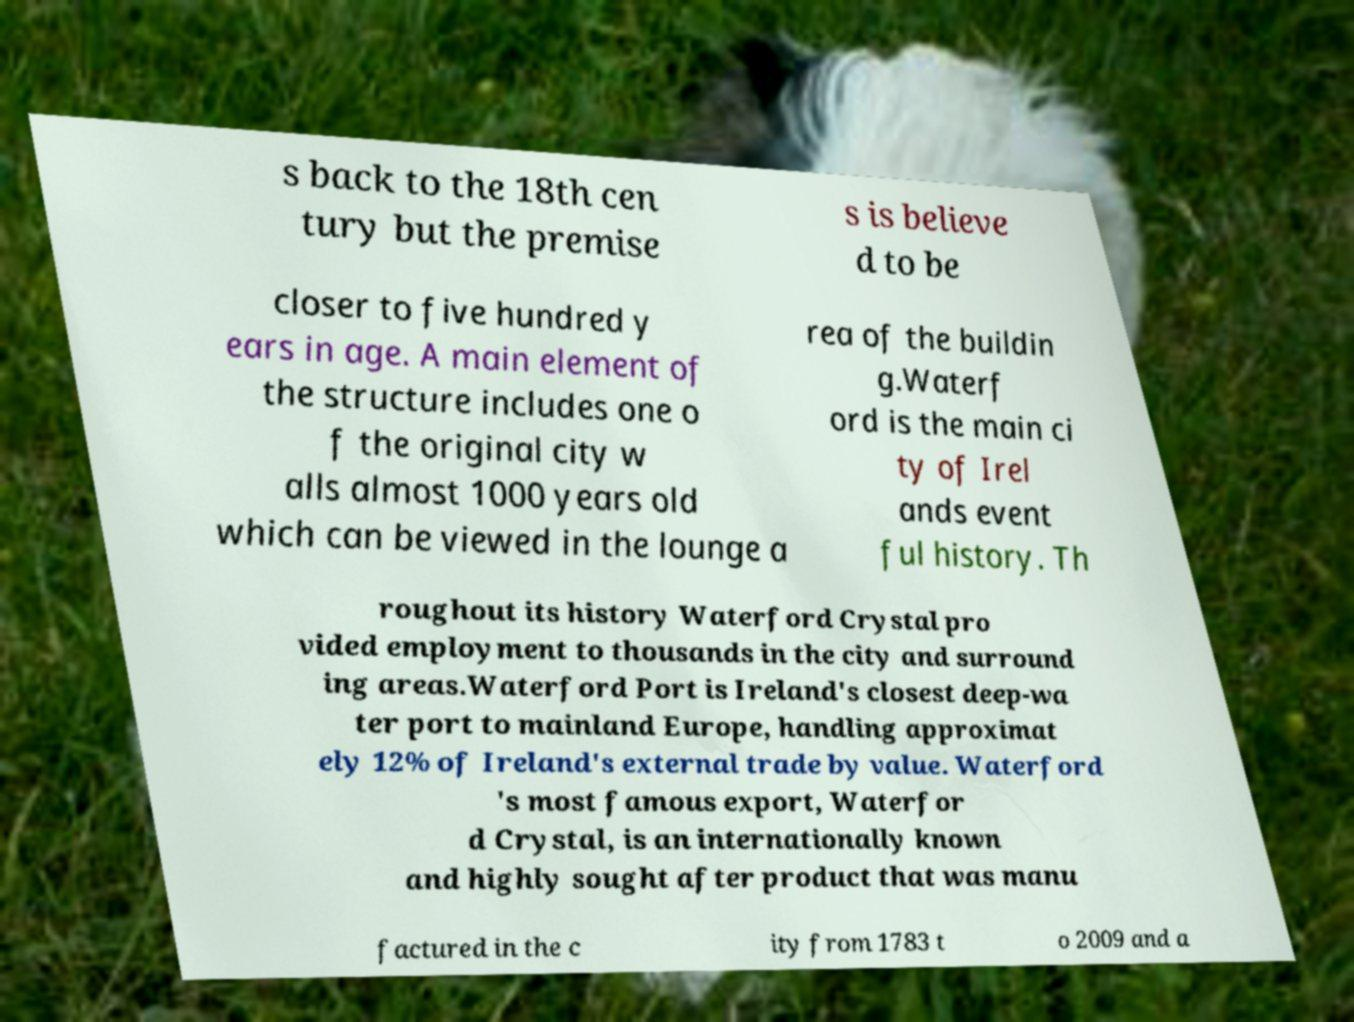Could you assist in decoding the text presented in this image and type it out clearly? s back to the 18th cen tury but the premise s is believe d to be closer to five hundred y ears in age. A main element of the structure includes one o f the original city w alls almost 1000 years old which can be viewed in the lounge a rea of the buildin g.Waterf ord is the main ci ty of Irel ands event ful history. Th roughout its history Waterford Crystal pro vided employment to thousands in the city and surround ing areas.Waterford Port is Ireland's closest deep-wa ter port to mainland Europe, handling approximat ely 12% of Ireland's external trade by value. Waterford 's most famous export, Waterfor d Crystal, is an internationally known and highly sought after product that was manu factured in the c ity from 1783 t o 2009 and a 